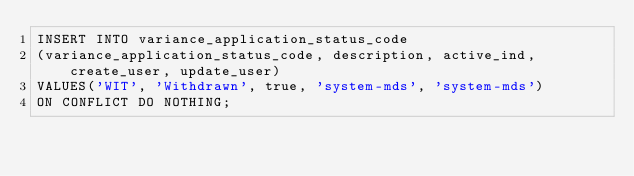Convert code to text. <code><loc_0><loc_0><loc_500><loc_500><_SQL_>INSERT INTO variance_application_status_code
(variance_application_status_code, description, active_ind, create_user, update_user)
VALUES('WIT', 'Withdrawn', true, 'system-mds', 'system-mds')
ON CONFLICT DO NOTHING;</code> 